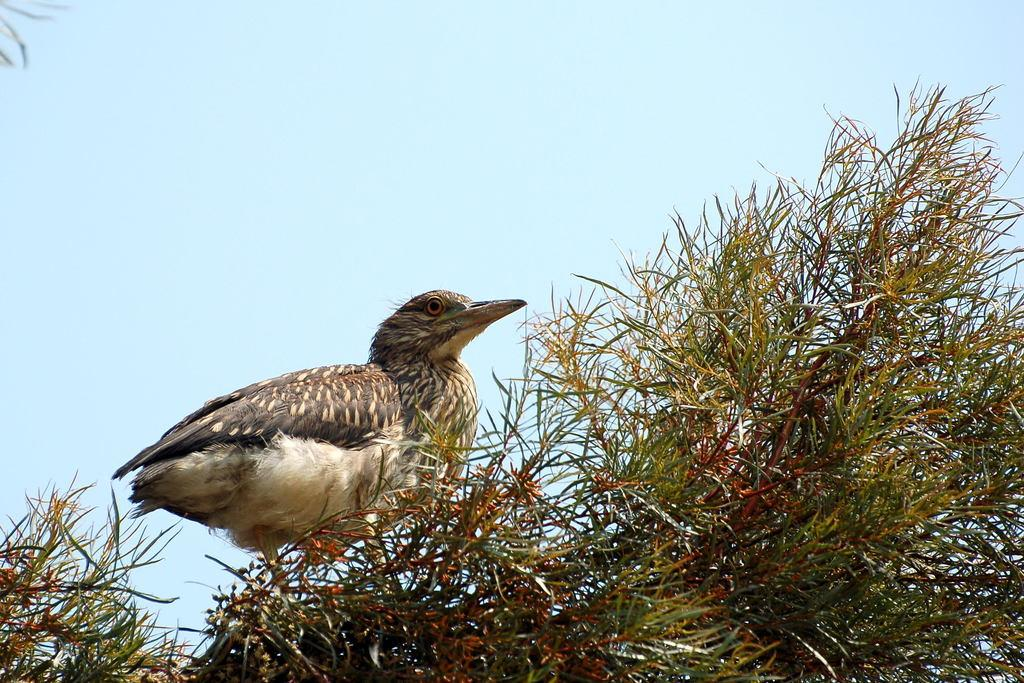What animal can be seen in the image? There is a bird on a tree in the image. Where is the bird located in the image? The bird is on a tree in the image. What can be seen in the background of the image? There is sky visible in the background of the image. What type of arm is holding the bird in the image? There is no arm holding the bird in the image; the bird is on a tree. What is the base of the bird made of in the image? The bird is on a tree, and trees do not have a base; they have trunks and branches. 